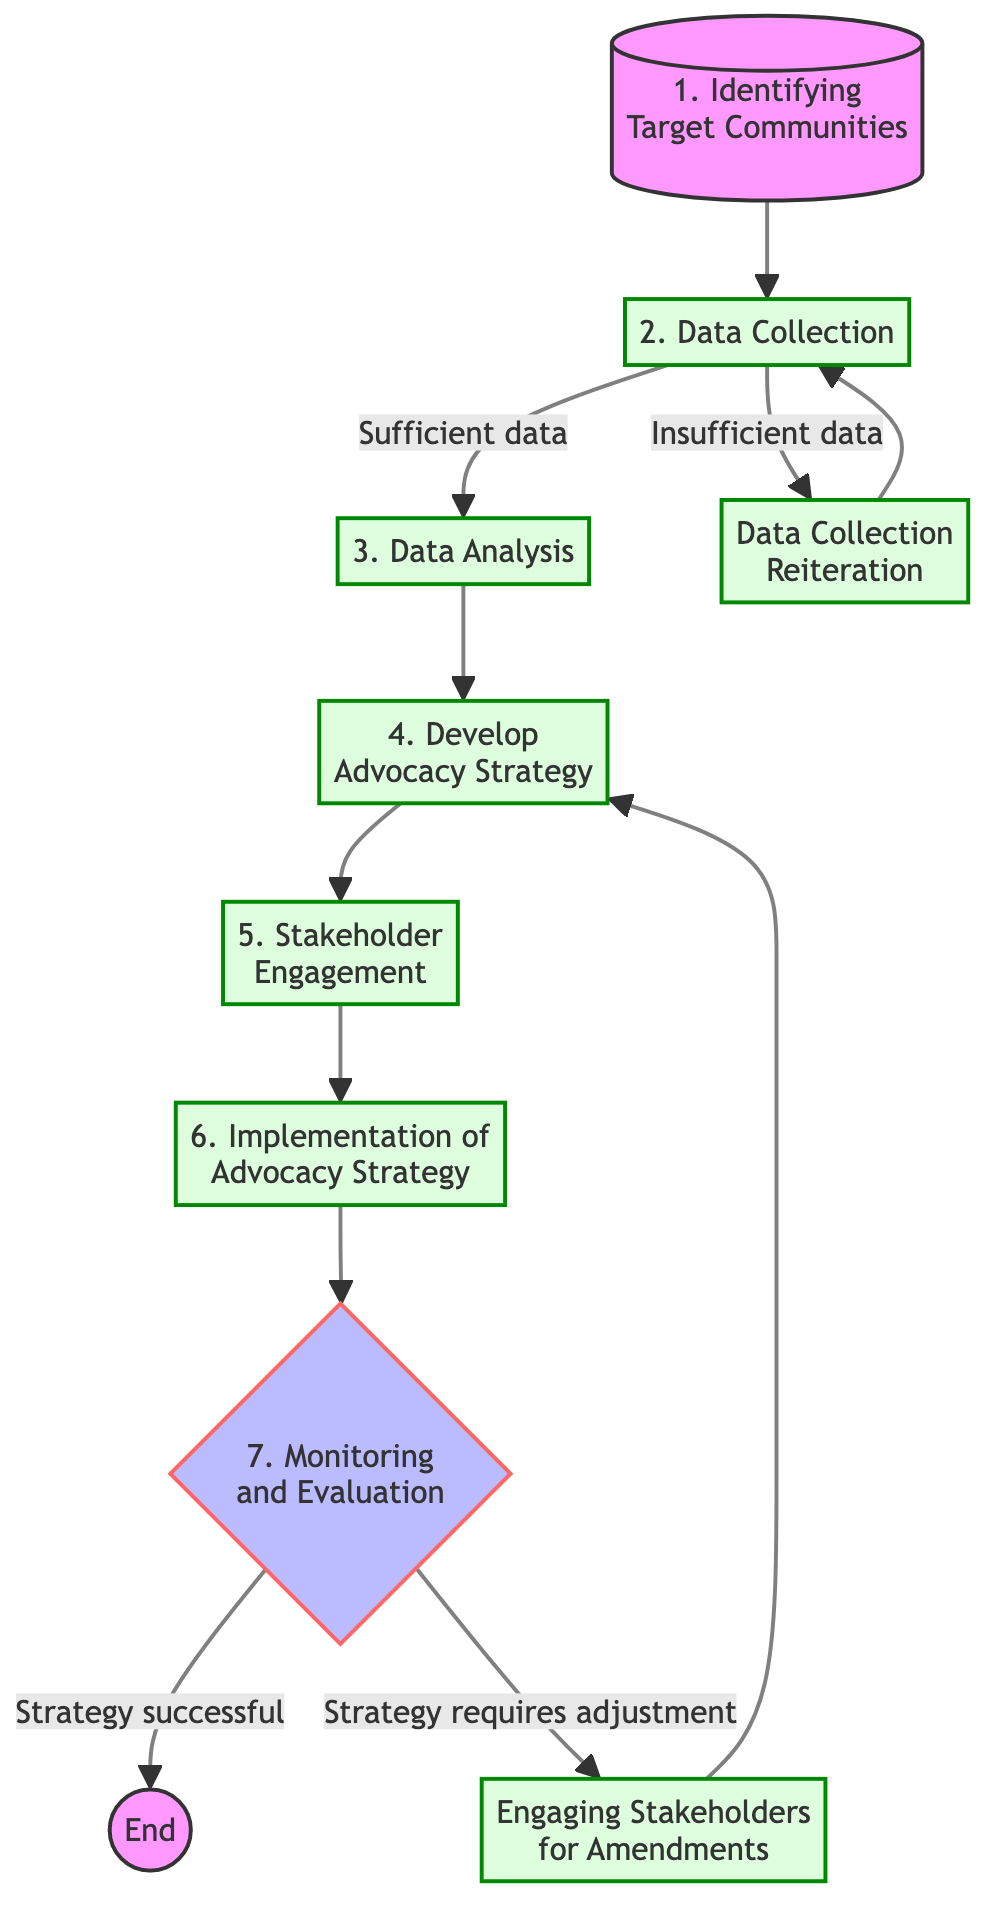What is the first step in the flowchart? The flowchart starts with the first step, which is "Identifying Target Communities". This step is visually indicated at the top of the flowchart and is connected to the second step.
Answer: Identifying Target Communities How many steps are there in the flowchart? The flowchart consists of a total of 8 steps, including the reiteration and stakeholder engagement nodes, all leading towards the endpoint.
Answer: 8 What happens if there is insufficient data during Data Collection? If there is insufficient data in the Data Collection step, the flowchart directs to "Data Collection Reiteration", where the process loops back to collect more data or refine methods before proceeding.
Answer: Data Collection Reiteration What step directly follows Data Analysis? The step directly following Data Analysis is "Develop Advocacy Strategy". This connection is indicated by a direct arrow transition in the flowchart.
Answer: Develop Advocacy Strategy What are the two possible outcomes after Monitoring and Evaluation? The two possible outcomes after Monitoring and Evaluation are either that the "Strategy successful" leads to the End, or "Strategy requires adjustment" leads to "Engaging Stakeholders for Amendments".
Answer: Strategy successful, Strategy requires adjustment If the strategy requires adjustment, which step will be revisited? If the strategy requires adjustment, the flowchart indicates that it will revert to the "Develop Advocacy Strategy" step where the advocacy plans will be revised based on stakeholder feedback.
Answer: Develop Advocacy Strategy How many decision points are in the flowchart? There are two decision points in the flowchart: one after Data Collection regarding data sufficiency and the other after Monitoring and Evaluation regarding the strategy's success.
Answer: 2 What is the last step before reaching the end of the flowchart? The last step before reaching the end of the flowchart is "Monitoring and Evaluation", which assesses the success of the advocacy strategy before finalizing.
Answer: Monitoring and Evaluation 